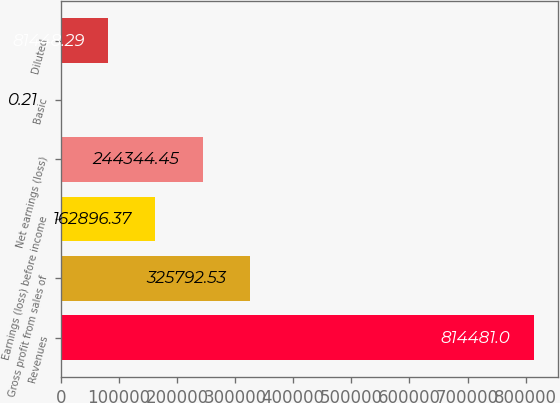Convert chart. <chart><loc_0><loc_0><loc_500><loc_500><bar_chart><fcel>Revenues<fcel>Gross profit from sales of<fcel>Earnings (loss) before income<fcel>Net earnings (loss)<fcel>Basic<fcel>Diluted<nl><fcel>814481<fcel>325793<fcel>162896<fcel>244344<fcel>0.21<fcel>81448.3<nl></chart> 